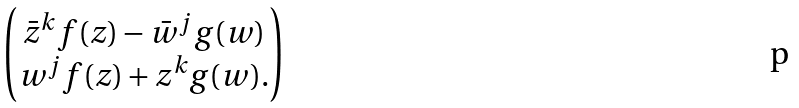Convert formula to latex. <formula><loc_0><loc_0><loc_500><loc_500>\begin{pmatrix} \bar { z } ^ { k } f ( z ) - \bar { w } ^ { j } g ( w ) \\ w ^ { j } f ( z ) + z ^ { k } g ( w ) . \end{pmatrix}</formula> 